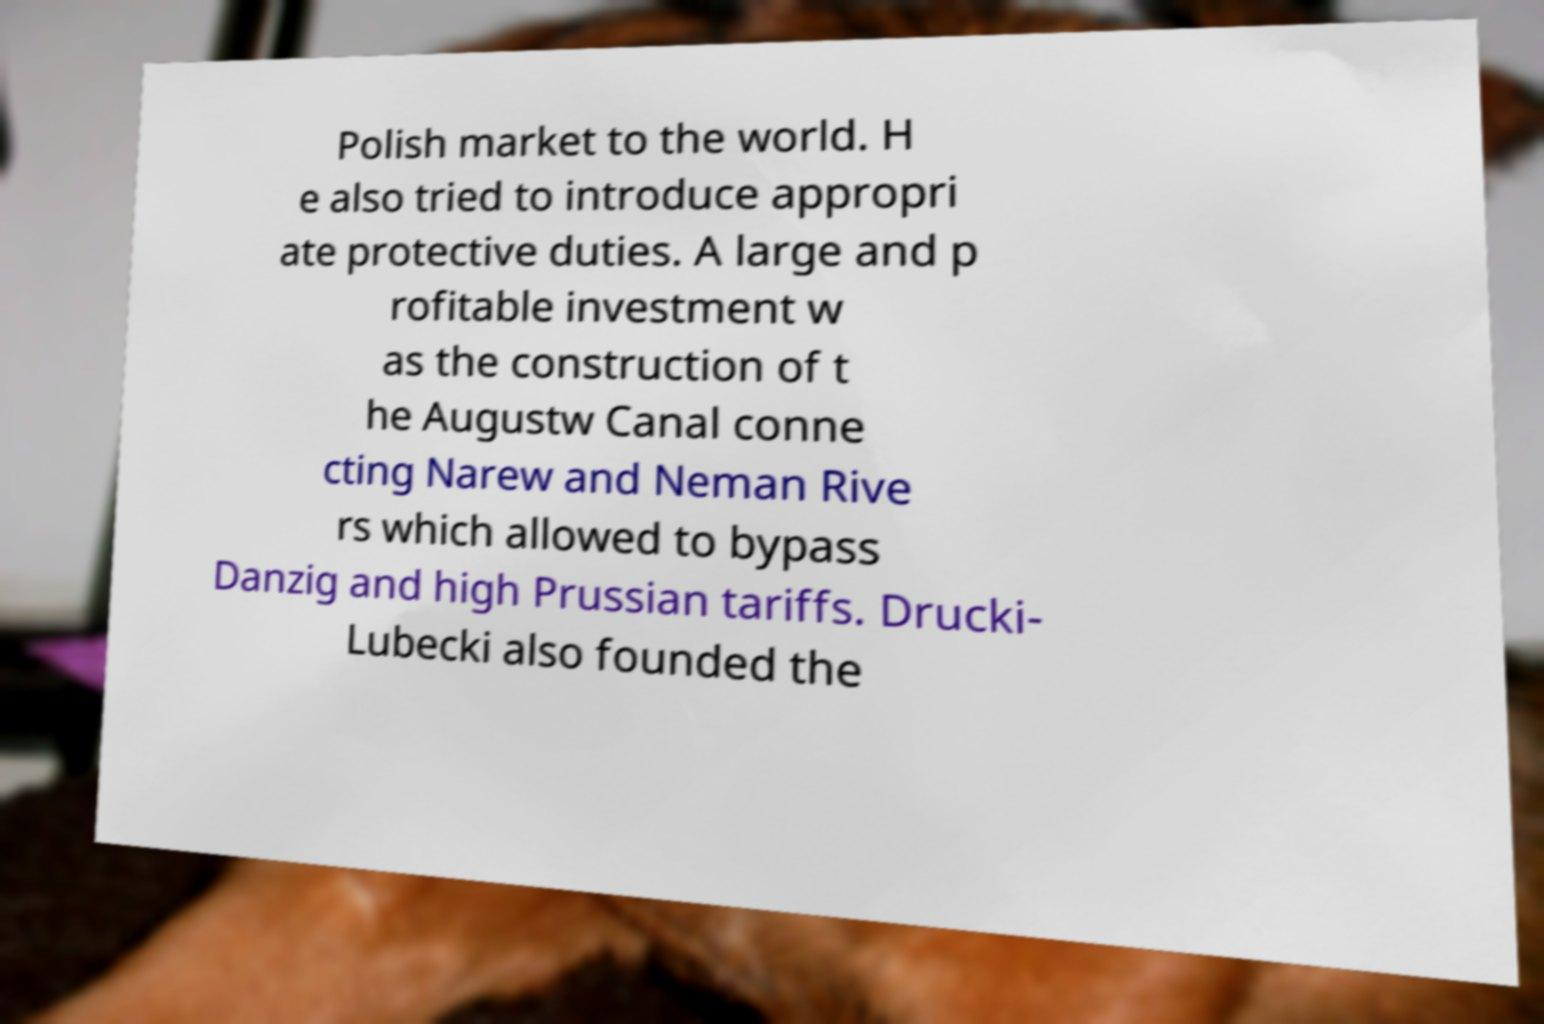Please read and relay the text visible in this image. What does it say? Polish market to the world. H e also tried to introduce appropri ate protective duties. A large and p rofitable investment w as the construction of t he Augustw Canal conne cting Narew and Neman Rive rs which allowed to bypass Danzig and high Prussian tariffs. Drucki- Lubecki also founded the 